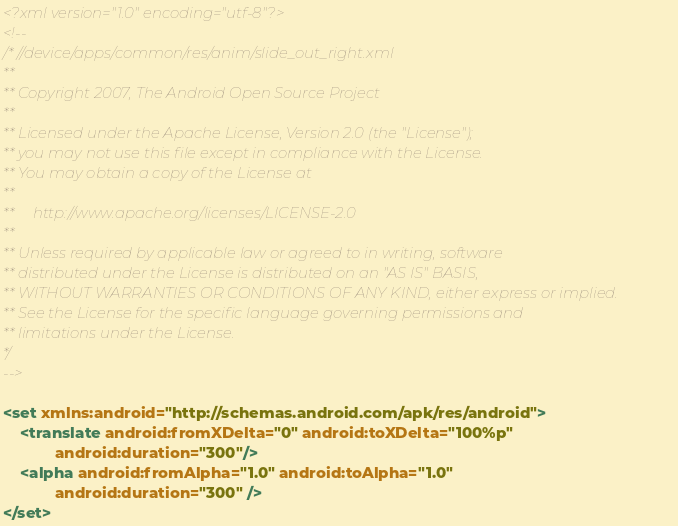<code> <loc_0><loc_0><loc_500><loc_500><_XML_><?xml version="1.0" encoding="utf-8"?>
<!--
/* //device/apps/common/res/anim/slide_out_right.xml
**
** Copyright 2007, The Android Open Source Project
**
** Licensed under the Apache License, Version 2.0 (the "License"); 
** you may not use this file except in compliance with the License. 
** You may obtain a copy of the License at 
**
**     http://www.apache.org/licenses/LICENSE-2.0 
**
** Unless required by applicable law or agreed to in writing, software 
** distributed under the License is distributed on an "AS IS" BASIS, 
** WITHOUT WARRANTIES OR CONDITIONS OF ANY KIND, either express or implied. 
** See the License for the specific language governing permissions and 
** limitations under the License.
*/
-->

<set xmlns:android="http://schemas.android.com/apk/res/android">
	<translate android:fromXDelta="0" android:toXDelta="100%p"
            android:duration="300"/>
	<alpha android:fromAlpha="1.0" android:toAlpha="1.0"
            android:duration="300" />
</set></code> 